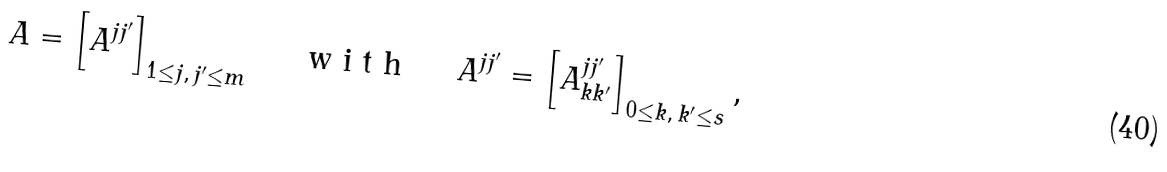Convert formula to latex. <formula><loc_0><loc_0><loc_500><loc_500>A = \left [ A ^ { j j ^ { \prime } } \right ] _ { 1 \leq j , \, j ^ { \prime } \leq m } \quad \emph { \emph { w i t h } } \quad A ^ { j j ^ { \prime } } = \left [ A ^ { j j ^ { \prime } } _ { k k ^ { \prime } } \right ] _ { 0 \leq k , \, k ^ { \prime } \leq s } ,</formula> 